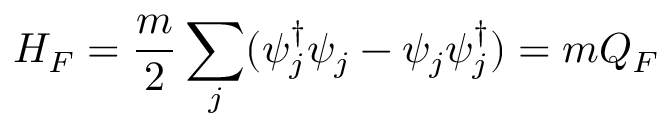Convert formula to latex. <formula><loc_0><loc_0><loc_500><loc_500>H _ { F } = \frac { m } { 2 } \sum _ { j } ( \psi _ { j } ^ { \dagger } \psi _ { j } - \psi _ { j } \psi _ { j } ^ { \dagger } ) = m Q _ { F }</formula> 